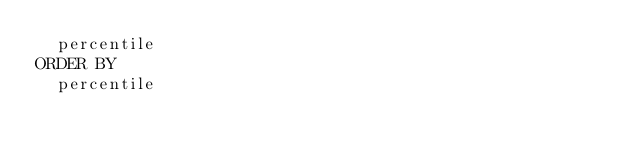Convert code to text. <code><loc_0><loc_0><loc_500><loc_500><_SQL_>  percentile
ORDER BY
  percentile
</code> 